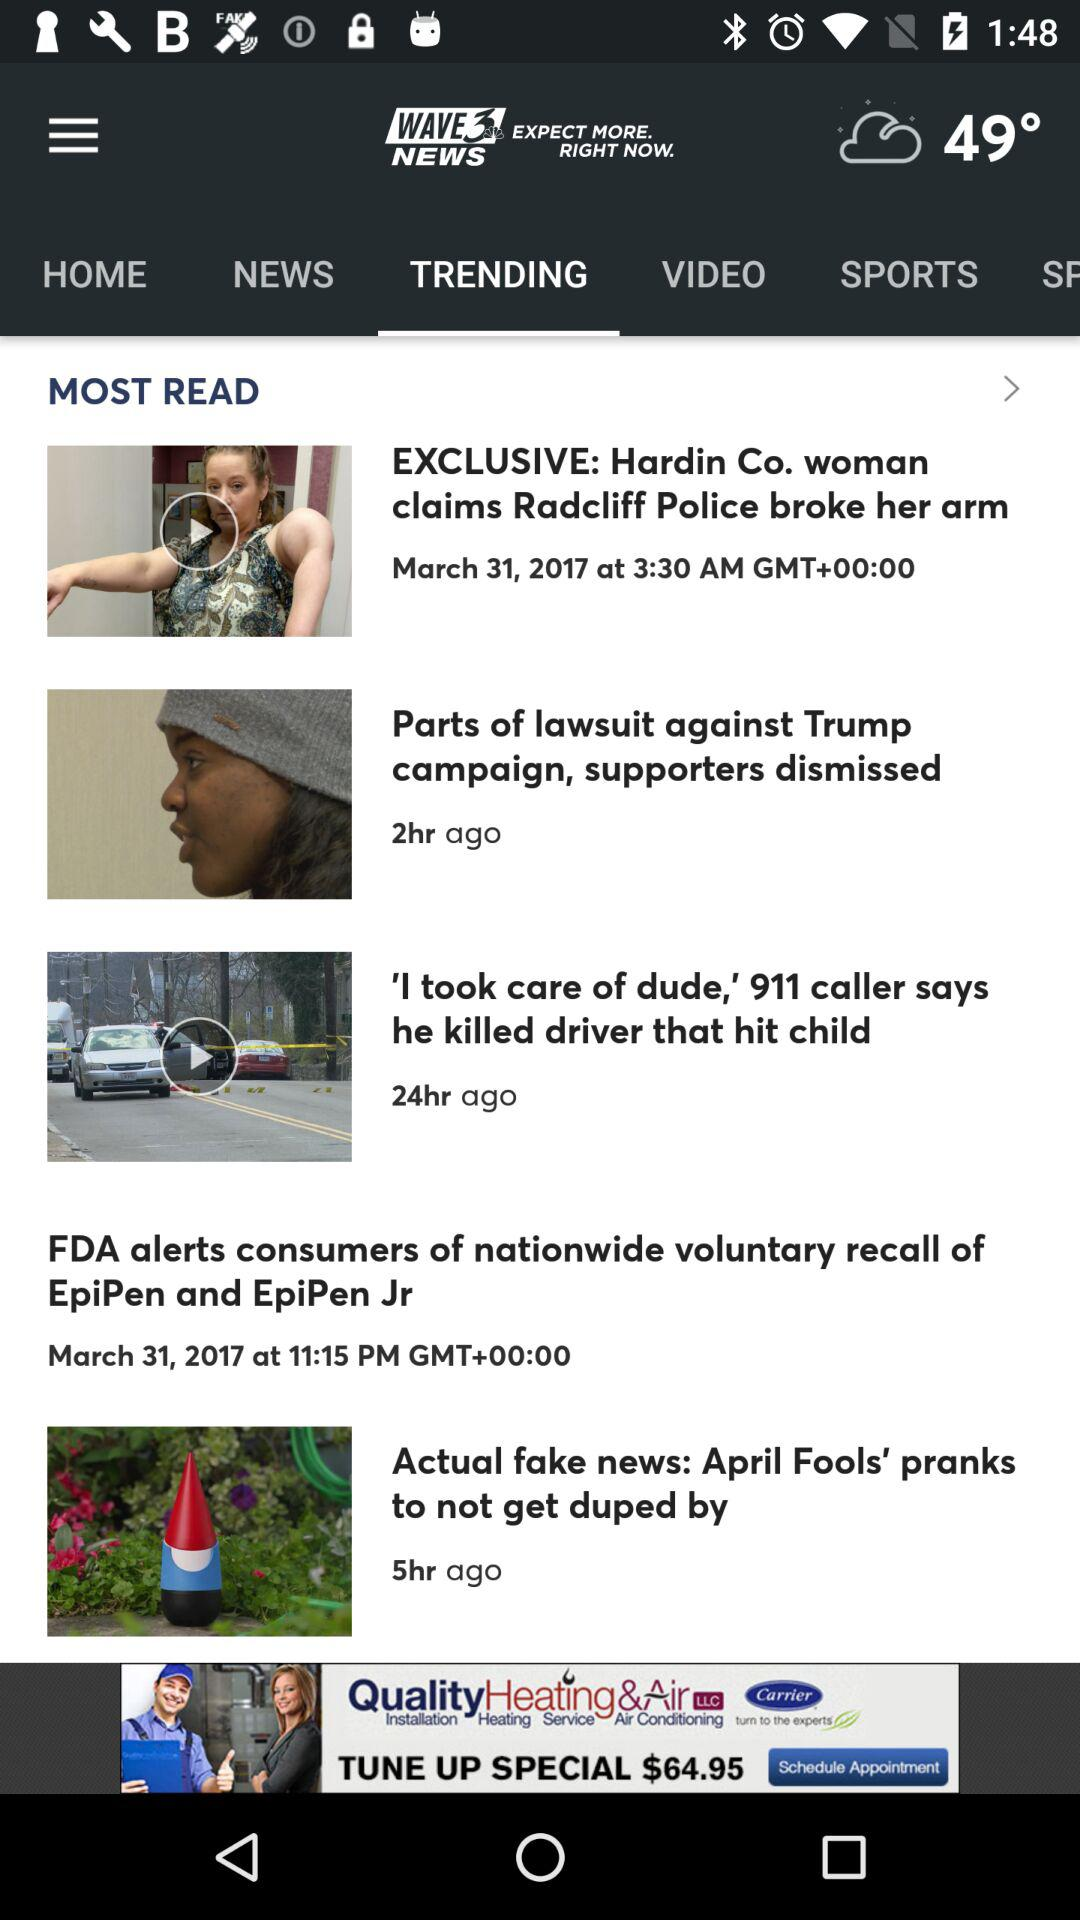What is the temperature scale?
When the provided information is insufficient, respond with <no answer>. <no answer> 